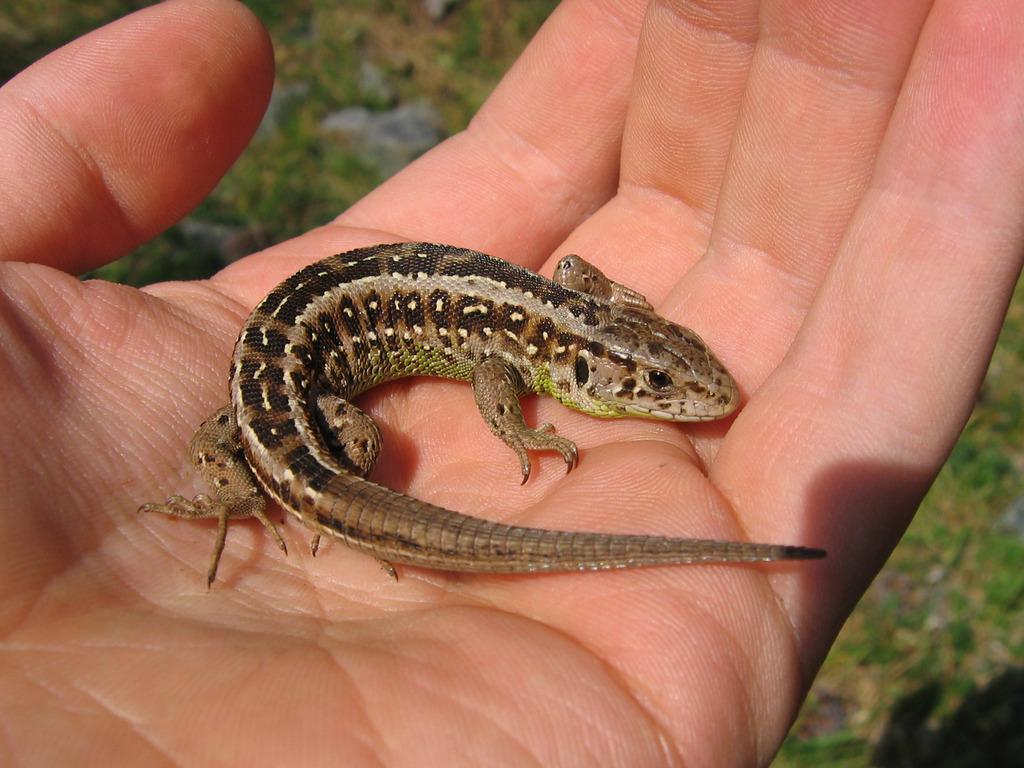In one or two sentences, can you explain what this image depicts? In this image we can see a reptile. We can see a hand of a person in the image. There is a blur background in the image. 